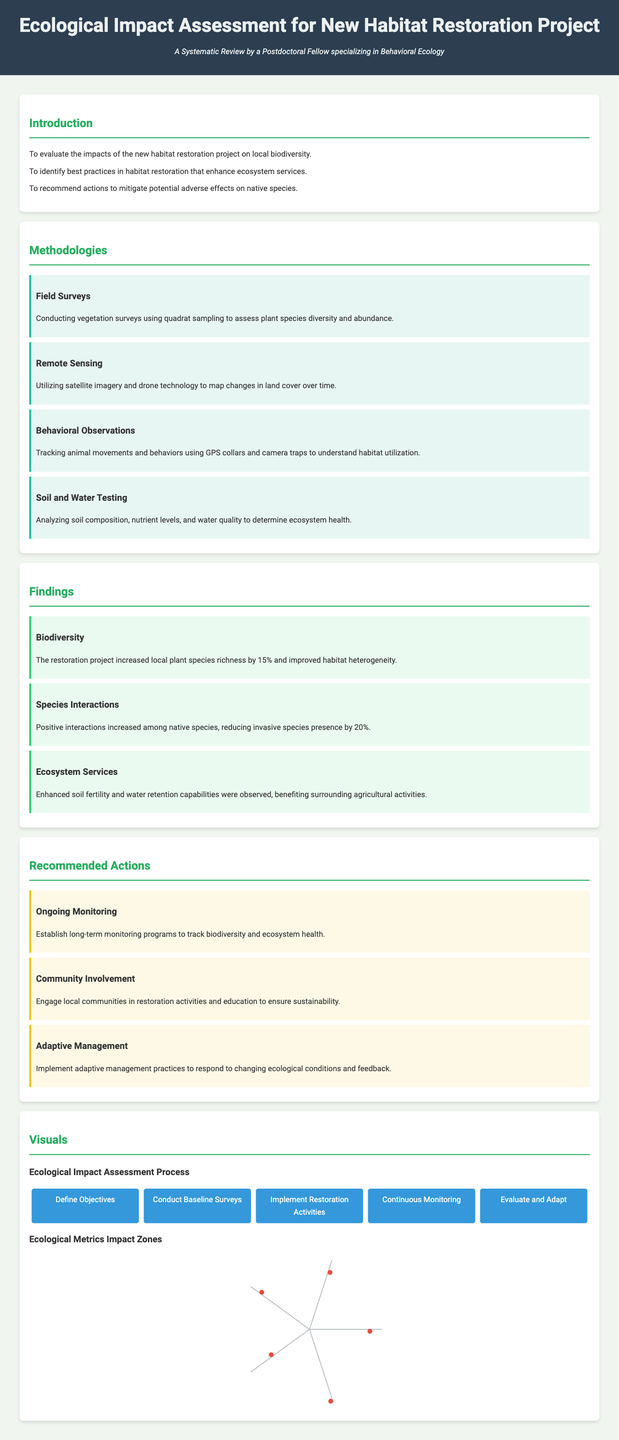What is the main aim of the project? The main aim is to evaluate the impacts of the new habitat restoration project on local biodiversity.
Answer: evaluate the impacts of the new habitat restoration project on local biodiversity How much did local plant species richness increase? The document states that the restoration project increased local plant species richness by a specific percentage.
Answer: 15% What methodology involves using GPS collars and camera traps? The methodology that involves using these tools is related to tracking animal movements and behaviors.
Answer: Behavioral Observations What is one recommended action for ensuring sustainability? The document suggests certain actions to ensure sustainability, one of which involves local communities.
Answer: Community Involvement How many steps are in the ecological impact assessment process flowchart? The flowchart details the process for ecological impact assessment and lists a number of sequential steps.
Answer: Five steps What was the effect on invasive species presence according to the findings? The findings state the impact on invasive species presence by a specific percentage.
Answer: 20% What type of graph is used to illustrate ecological metrics? The visual representation method used for illustrating ecological metrics is named specifically in the document.
Answer: Spider diagram What should be established for tracking biodiversity? The document provides a specific type of program that should be established for this purpose.
Answer: Long-term monitoring programs 